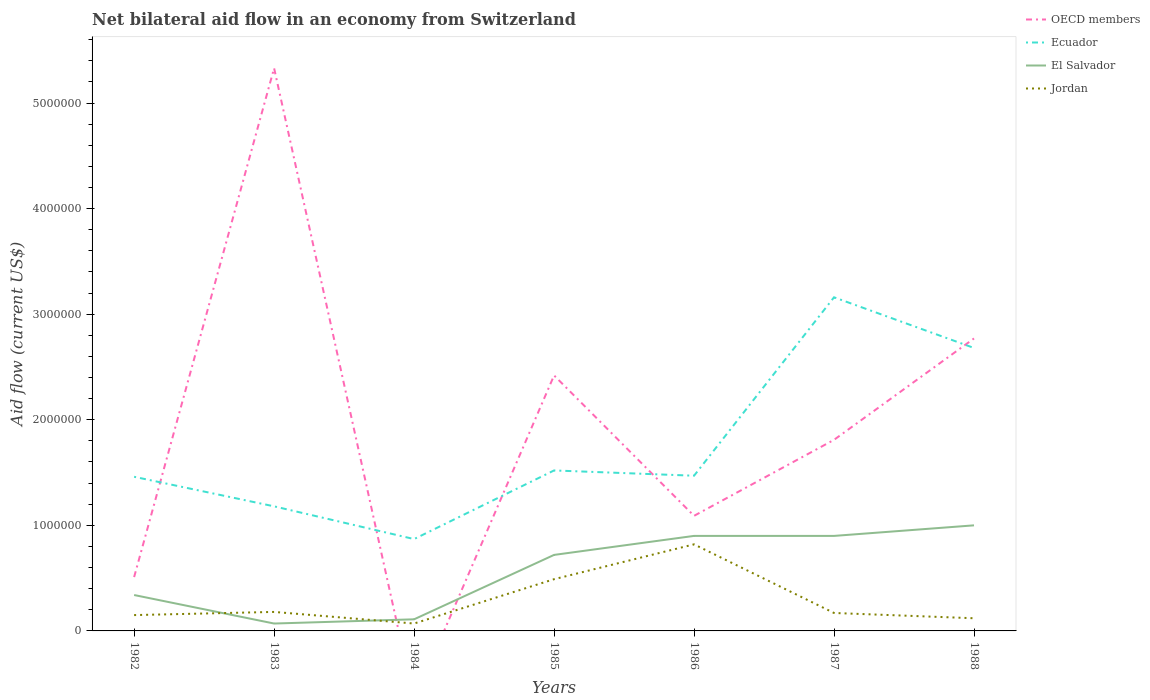How many different coloured lines are there?
Your answer should be very brief. 4. Is the number of lines equal to the number of legend labels?
Offer a very short reply. No. What is the difference between the highest and the second highest net bilateral aid flow in Ecuador?
Provide a short and direct response. 2.29e+06. What is the difference between the highest and the lowest net bilateral aid flow in Jordan?
Ensure brevity in your answer.  2. How many lines are there?
Keep it short and to the point. 4. How many years are there in the graph?
Make the answer very short. 7. Does the graph contain any zero values?
Offer a terse response. Yes. How many legend labels are there?
Your answer should be very brief. 4. What is the title of the graph?
Provide a succinct answer. Net bilateral aid flow in an economy from Switzerland. Does "United States" appear as one of the legend labels in the graph?
Your answer should be compact. No. What is the label or title of the X-axis?
Provide a short and direct response. Years. What is the label or title of the Y-axis?
Give a very brief answer. Aid flow (current US$). What is the Aid flow (current US$) of OECD members in 1982?
Your answer should be compact. 5.10e+05. What is the Aid flow (current US$) in Ecuador in 1982?
Provide a succinct answer. 1.46e+06. What is the Aid flow (current US$) of El Salvador in 1982?
Offer a very short reply. 3.40e+05. What is the Aid flow (current US$) of Jordan in 1982?
Make the answer very short. 1.50e+05. What is the Aid flow (current US$) of OECD members in 1983?
Give a very brief answer. 5.33e+06. What is the Aid flow (current US$) in Ecuador in 1983?
Make the answer very short. 1.18e+06. What is the Aid flow (current US$) in Jordan in 1983?
Offer a terse response. 1.80e+05. What is the Aid flow (current US$) in OECD members in 1984?
Provide a short and direct response. 0. What is the Aid flow (current US$) of Ecuador in 1984?
Provide a short and direct response. 8.70e+05. What is the Aid flow (current US$) of El Salvador in 1984?
Give a very brief answer. 1.10e+05. What is the Aid flow (current US$) of OECD members in 1985?
Make the answer very short. 2.42e+06. What is the Aid flow (current US$) in Ecuador in 1985?
Offer a very short reply. 1.52e+06. What is the Aid flow (current US$) in El Salvador in 1985?
Provide a succinct answer. 7.20e+05. What is the Aid flow (current US$) of OECD members in 1986?
Make the answer very short. 1.09e+06. What is the Aid flow (current US$) in Ecuador in 1986?
Your response must be concise. 1.47e+06. What is the Aid flow (current US$) in El Salvador in 1986?
Ensure brevity in your answer.  9.00e+05. What is the Aid flow (current US$) of Jordan in 1986?
Offer a terse response. 8.20e+05. What is the Aid flow (current US$) of OECD members in 1987?
Offer a terse response. 1.81e+06. What is the Aid flow (current US$) of Ecuador in 1987?
Your answer should be compact. 3.16e+06. What is the Aid flow (current US$) of Jordan in 1987?
Your answer should be compact. 1.70e+05. What is the Aid flow (current US$) of OECD members in 1988?
Keep it short and to the point. 2.77e+06. What is the Aid flow (current US$) in Ecuador in 1988?
Your answer should be compact. 2.68e+06. Across all years, what is the maximum Aid flow (current US$) of OECD members?
Your response must be concise. 5.33e+06. Across all years, what is the maximum Aid flow (current US$) of Ecuador?
Offer a very short reply. 3.16e+06. Across all years, what is the maximum Aid flow (current US$) in Jordan?
Your response must be concise. 8.20e+05. Across all years, what is the minimum Aid flow (current US$) of Ecuador?
Provide a short and direct response. 8.70e+05. Across all years, what is the minimum Aid flow (current US$) in El Salvador?
Make the answer very short. 7.00e+04. What is the total Aid flow (current US$) of OECD members in the graph?
Provide a succinct answer. 1.39e+07. What is the total Aid flow (current US$) of Ecuador in the graph?
Offer a very short reply. 1.23e+07. What is the total Aid flow (current US$) in El Salvador in the graph?
Offer a very short reply. 4.04e+06. What is the difference between the Aid flow (current US$) of OECD members in 1982 and that in 1983?
Your answer should be very brief. -4.82e+06. What is the difference between the Aid flow (current US$) in El Salvador in 1982 and that in 1983?
Ensure brevity in your answer.  2.70e+05. What is the difference between the Aid flow (current US$) in Ecuador in 1982 and that in 1984?
Provide a succinct answer. 5.90e+05. What is the difference between the Aid flow (current US$) of El Salvador in 1982 and that in 1984?
Offer a very short reply. 2.30e+05. What is the difference between the Aid flow (current US$) of Jordan in 1982 and that in 1984?
Provide a short and direct response. 8.00e+04. What is the difference between the Aid flow (current US$) of OECD members in 1982 and that in 1985?
Ensure brevity in your answer.  -1.91e+06. What is the difference between the Aid flow (current US$) in Ecuador in 1982 and that in 1985?
Offer a very short reply. -6.00e+04. What is the difference between the Aid flow (current US$) in El Salvador in 1982 and that in 1985?
Ensure brevity in your answer.  -3.80e+05. What is the difference between the Aid flow (current US$) in OECD members in 1982 and that in 1986?
Your response must be concise. -5.80e+05. What is the difference between the Aid flow (current US$) of El Salvador in 1982 and that in 1986?
Make the answer very short. -5.60e+05. What is the difference between the Aid flow (current US$) in Jordan in 1982 and that in 1986?
Offer a very short reply. -6.70e+05. What is the difference between the Aid flow (current US$) in OECD members in 1982 and that in 1987?
Your response must be concise. -1.30e+06. What is the difference between the Aid flow (current US$) of Ecuador in 1982 and that in 1987?
Your answer should be very brief. -1.70e+06. What is the difference between the Aid flow (current US$) in El Salvador in 1982 and that in 1987?
Your response must be concise. -5.60e+05. What is the difference between the Aid flow (current US$) of OECD members in 1982 and that in 1988?
Your answer should be very brief. -2.26e+06. What is the difference between the Aid flow (current US$) in Ecuador in 1982 and that in 1988?
Keep it short and to the point. -1.22e+06. What is the difference between the Aid flow (current US$) in El Salvador in 1982 and that in 1988?
Give a very brief answer. -6.60e+05. What is the difference between the Aid flow (current US$) in Ecuador in 1983 and that in 1984?
Your answer should be very brief. 3.10e+05. What is the difference between the Aid flow (current US$) in El Salvador in 1983 and that in 1984?
Your answer should be very brief. -4.00e+04. What is the difference between the Aid flow (current US$) of Jordan in 1983 and that in 1984?
Your response must be concise. 1.10e+05. What is the difference between the Aid flow (current US$) of OECD members in 1983 and that in 1985?
Your answer should be compact. 2.91e+06. What is the difference between the Aid flow (current US$) in El Salvador in 1983 and that in 1985?
Make the answer very short. -6.50e+05. What is the difference between the Aid flow (current US$) in Jordan in 1983 and that in 1985?
Offer a very short reply. -3.10e+05. What is the difference between the Aid flow (current US$) in OECD members in 1983 and that in 1986?
Make the answer very short. 4.24e+06. What is the difference between the Aid flow (current US$) in El Salvador in 1983 and that in 1986?
Your response must be concise. -8.30e+05. What is the difference between the Aid flow (current US$) of Jordan in 1983 and that in 1986?
Your response must be concise. -6.40e+05. What is the difference between the Aid flow (current US$) of OECD members in 1983 and that in 1987?
Your answer should be compact. 3.52e+06. What is the difference between the Aid flow (current US$) in Ecuador in 1983 and that in 1987?
Provide a succinct answer. -1.98e+06. What is the difference between the Aid flow (current US$) of El Salvador in 1983 and that in 1987?
Your answer should be very brief. -8.30e+05. What is the difference between the Aid flow (current US$) of OECD members in 1983 and that in 1988?
Keep it short and to the point. 2.56e+06. What is the difference between the Aid flow (current US$) of Ecuador in 1983 and that in 1988?
Keep it short and to the point. -1.50e+06. What is the difference between the Aid flow (current US$) of El Salvador in 1983 and that in 1988?
Your answer should be very brief. -9.30e+05. What is the difference between the Aid flow (current US$) of Jordan in 1983 and that in 1988?
Give a very brief answer. 6.00e+04. What is the difference between the Aid flow (current US$) in Ecuador in 1984 and that in 1985?
Ensure brevity in your answer.  -6.50e+05. What is the difference between the Aid flow (current US$) in El Salvador in 1984 and that in 1985?
Provide a succinct answer. -6.10e+05. What is the difference between the Aid flow (current US$) of Jordan in 1984 and that in 1985?
Offer a terse response. -4.20e+05. What is the difference between the Aid flow (current US$) in Ecuador in 1984 and that in 1986?
Give a very brief answer. -6.00e+05. What is the difference between the Aid flow (current US$) of El Salvador in 1984 and that in 1986?
Your answer should be compact. -7.90e+05. What is the difference between the Aid flow (current US$) of Jordan in 1984 and that in 1986?
Ensure brevity in your answer.  -7.50e+05. What is the difference between the Aid flow (current US$) of Ecuador in 1984 and that in 1987?
Your answer should be very brief. -2.29e+06. What is the difference between the Aid flow (current US$) of El Salvador in 1984 and that in 1987?
Keep it short and to the point. -7.90e+05. What is the difference between the Aid flow (current US$) of Ecuador in 1984 and that in 1988?
Give a very brief answer. -1.81e+06. What is the difference between the Aid flow (current US$) of El Salvador in 1984 and that in 1988?
Your answer should be very brief. -8.90e+05. What is the difference between the Aid flow (current US$) of Jordan in 1984 and that in 1988?
Give a very brief answer. -5.00e+04. What is the difference between the Aid flow (current US$) in OECD members in 1985 and that in 1986?
Ensure brevity in your answer.  1.33e+06. What is the difference between the Aid flow (current US$) in Ecuador in 1985 and that in 1986?
Offer a very short reply. 5.00e+04. What is the difference between the Aid flow (current US$) of Jordan in 1985 and that in 1986?
Offer a very short reply. -3.30e+05. What is the difference between the Aid flow (current US$) in OECD members in 1985 and that in 1987?
Your answer should be compact. 6.10e+05. What is the difference between the Aid flow (current US$) in Ecuador in 1985 and that in 1987?
Offer a terse response. -1.64e+06. What is the difference between the Aid flow (current US$) of El Salvador in 1985 and that in 1987?
Offer a very short reply. -1.80e+05. What is the difference between the Aid flow (current US$) of Jordan in 1985 and that in 1987?
Make the answer very short. 3.20e+05. What is the difference between the Aid flow (current US$) of OECD members in 1985 and that in 1988?
Provide a succinct answer. -3.50e+05. What is the difference between the Aid flow (current US$) of Ecuador in 1985 and that in 1988?
Ensure brevity in your answer.  -1.16e+06. What is the difference between the Aid flow (current US$) in El Salvador in 1985 and that in 1988?
Your answer should be very brief. -2.80e+05. What is the difference between the Aid flow (current US$) of Jordan in 1985 and that in 1988?
Ensure brevity in your answer.  3.70e+05. What is the difference between the Aid flow (current US$) in OECD members in 1986 and that in 1987?
Ensure brevity in your answer.  -7.20e+05. What is the difference between the Aid flow (current US$) in Ecuador in 1986 and that in 1987?
Your answer should be compact. -1.69e+06. What is the difference between the Aid flow (current US$) of El Salvador in 1986 and that in 1987?
Offer a very short reply. 0. What is the difference between the Aid flow (current US$) of Jordan in 1986 and that in 1987?
Ensure brevity in your answer.  6.50e+05. What is the difference between the Aid flow (current US$) in OECD members in 1986 and that in 1988?
Ensure brevity in your answer.  -1.68e+06. What is the difference between the Aid flow (current US$) of Ecuador in 1986 and that in 1988?
Offer a terse response. -1.21e+06. What is the difference between the Aid flow (current US$) in OECD members in 1987 and that in 1988?
Offer a terse response. -9.60e+05. What is the difference between the Aid flow (current US$) in Ecuador in 1987 and that in 1988?
Offer a very short reply. 4.80e+05. What is the difference between the Aid flow (current US$) of Jordan in 1987 and that in 1988?
Offer a terse response. 5.00e+04. What is the difference between the Aid flow (current US$) of OECD members in 1982 and the Aid flow (current US$) of Ecuador in 1983?
Provide a short and direct response. -6.70e+05. What is the difference between the Aid flow (current US$) in OECD members in 1982 and the Aid flow (current US$) in Jordan in 1983?
Your answer should be compact. 3.30e+05. What is the difference between the Aid flow (current US$) in Ecuador in 1982 and the Aid flow (current US$) in El Salvador in 1983?
Your response must be concise. 1.39e+06. What is the difference between the Aid flow (current US$) in Ecuador in 1982 and the Aid flow (current US$) in Jordan in 1983?
Offer a very short reply. 1.28e+06. What is the difference between the Aid flow (current US$) in El Salvador in 1982 and the Aid flow (current US$) in Jordan in 1983?
Your response must be concise. 1.60e+05. What is the difference between the Aid flow (current US$) of OECD members in 1982 and the Aid flow (current US$) of Ecuador in 1984?
Your response must be concise. -3.60e+05. What is the difference between the Aid flow (current US$) in OECD members in 1982 and the Aid flow (current US$) in Jordan in 1984?
Give a very brief answer. 4.40e+05. What is the difference between the Aid flow (current US$) of Ecuador in 1982 and the Aid flow (current US$) of El Salvador in 1984?
Keep it short and to the point. 1.35e+06. What is the difference between the Aid flow (current US$) in Ecuador in 1982 and the Aid flow (current US$) in Jordan in 1984?
Keep it short and to the point. 1.39e+06. What is the difference between the Aid flow (current US$) of OECD members in 1982 and the Aid flow (current US$) of Ecuador in 1985?
Your response must be concise. -1.01e+06. What is the difference between the Aid flow (current US$) in Ecuador in 1982 and the Aid flow (current US$) in El Salvador in 1985?
Provide a short and direct response. 7.40e+05. What is the difference between the Aid flow (current US$) of Ecuador in 1982 and the Aid flow (current US$) of Jordan in 1985?
Keep it short and to the point. 9.70e+05. What is the difference between the Aid flow (current US$) in OECD members in 1982 and the Aid flow (current US$) in Ecuador in 1986?
Ensure brevity in your answer.  -9.60e+05. What is the difference between the Aid flow (current US$) in OECD members in 1982 and the Aid flow (current US$) in El Salvador in 1986?
Offer a terse response. -3.90e+05. What is the difference between the Aid flow (current US$) in OECD members in 1982 and the Aid flow (current US$) in Jordan in 1986?
Your response must be concise. -3.10e+05. What is the difference between the Aid flow (current US$) of Ecuador in 1982 and the Aid flow (current US$) of El Salvador in 1986?
Provide a short and direct response. 5.60e+05. What is the difference between the Aid flow (current US$) in Ecuador in 1982 and the Aid flow (current US$) in Jordan in 1986?
Provide a succinct answer. 6.40e+05. What is the difference between the Aid flow (current US$) of El Salvador in 1982 and the Aid flow (current US$) of Jordan in 1986?
Provide a short and direct response. -4.80e+05. What is the difference between the Aid flow (current US$) of OECD members in 1982 and the Aid flow (current US$) of Ecuador in 1987?
Keep it short and to the point. -2.65e+06. What is the difference between the Aid flow (current US$) in OECD members in 1982 and the Aid flow (current US$) in El Salvador in 1987?
Provide a succinct answer. -3.90e+05. What is the difference between the Aid flow (current US$) of OECD members in 1982 and the Aid flow (current US$) of Jordan in 1987?
Offer a very short reply. 3.40e+05. What is the difference between the Aid flow (current US$) in Ecuador in 1982 and the Aid flow (current US$) in El Salvador in 1987?
Your answer should be compact. 5.60e+05. What is the difference between the Aid flow (current US$) in Ecuador in 1982 and the Aid flow (current US$) in Jordan in 1987?
Ensure brevity in your answer.  1.29e+06. What is the difference between the Aid flow (current US$) of OECD members in 1982 and the Aid flow (current US$) of Ecuador in 1988?
Your response must be concise. -2.17e+06. What is the difference between the Aid flow (current US$) in OECD members in 1982 and the Aid flow (current US$) in El Salvador in 1988?
Ensure brevity in your answer.  -4.90e+05. What is the difference between the Aid flow (current US$) in OECD members in 1982 and the Aid flow (current US$) in Jordan in 1988?
Your answer should be very brief. 3.90e+05. What is the difference between the Aid flow (current US$) of Ecuador in 1982 and the Aid flow (current US$) of El Salvador in 1988?
Offer a terse response. 4.60e+05. What is the difference between the Aid flow (current US$) in Ecuador in 1982 and the Aid flow (current US$) in Jordan in 1988?
Ensure brevity in your answer.  1.34e+06. What is the difference between the Aid flow (current US$) in El Salvador in 1982 and the Aid flow (current US$) in Jordan in 1988?
Give a very brief answer. 2.20e+05. What is the difference between the Aid flow (current US$) of OECD members in 1983 and the Aid flow (current US$) of Ecuador in 1984?
Your answer should be very brief. 4.46e+06. What is the difference between the Aid flow (current US$) of OECD members in 1983 and the Aid flow (current US$) of El Salvador in 1984?
Keep it short and to the point. 5.22e+06. What is the difference between the Aid flow (current US$) in OECD members in 1983 and the Aid flow (current US$) in Jordan in 1984?
Provide a short and direct response. 5.26e+06. What is the difference between the Aid flow (current US$) of Ecuador in 1983 and the Aid flow (current US$) of El Salvador in 1984?
Give a very brief answer. 1.07e+06. What is the difference between the Aid flow (current US$) of Ecuador in 1983 and the Aid flow (current US$) of Jordan in 1984?
Ensure brevity in your answer.  1.11e+06. What is the difference between the Aid flow (current US$) of El Salvador in 1983 and the Aid flow (current US$) of Jordan in 1984?
Provide a succinct answer. 0. What is the difference between the Aid flow (current US$) in OECD members in 1983 and the Aid flow (current US$) in Ecuador in 1985?
Your answer should be compact. 3.81e+06. What is the difference between the Aid flow (current US$) of OECD members in 1983 and the Aid flow (current US$) of El Salvador in 1985?
Offer a very short reply. 4.61e+06. What is the difference between the Aid flow (current US$) of OECD members in 1983 and the Aid flow (current US$) of Jordan in 1985?
Provide a succinct answer. 4.84e+06. What is the difference between the Aid flow (current US$) in Ecuador in 1983 and the Aid flow (current US$) in El Salvador in 1985?
Offer a very short reply. 4.60e+05. What is the difference between the Aid flow (current US$) of Ecuador in 1983 and the Aid flow (current US$) of Jordan in 1985?
Provide a succinct answer. 6.90e+05. What is the difference between the Aid flow (current US$) in El Salvador in 1983 and the Aid flow (current US$) in Jordan in 1985?
Give a very brief answer. -4.20e+05. What is the difference between the Aid flow (current US$) in OECD members in 1983 and the Aid flow (current US$) in Ecuador in 1986?
Make the answer very short. 3.86e+06. What is the difference between the Aid flow (current US$) of OECD members in 1983 and the Aid flow (current US$) of El Salvador in 1986?
Ensure brevity in your answer.  4.43e+06. What is the difference between the Aid flow (current US$) in OECD members in 1983 and the Aid flow (current US$) in Jordan in 1986?
Your answer should be compact. 4.51e+06. What is the difference between the Aid flow (current US$) of Ecuador in 1983 and the Aid flow (current US$) of El Salvador in 1986?
Provide a short and direct response. 2.80e+05. What is the difference between the Aid flow (current US$) of Ecuador in 1983 and the Aid flow (current US$) of Jordan in 1986?
Keep it short and to the point. 3.60e+05. What is the difference between the Aid flow (current US$) in El Salvador in 1983 and the Aid flow (current US$) in Jordan in 1986?
Make the answer very short. -7.50e+05. What is the difference between the Aid flow (current US$) of OECD members in 1983 and the Aid flow (current US$) of Ecuador in 1987?
Ensure brevity in your answer.  2.17e+06. What is the difference between the Aid flow (current US$) in OECD members in 1983 and the Aid flow (current US$) in El Salvador in 1987?
Give a very brief answer. 4.43e+06. What is the difference between the Aid flow (current US$) in OECD members in 1983 and the Aid flow (current US$) in Jordan in 1987?
Offer a terse response. 5.16e+06. What is the difference between the Aid flow (current US$) of Ecuador in 1983 and the Aid flow (current US$) of Jordan in 1987?
Give a very brief answer. 1.01e+06. What is the difference between the Aid flow (current US$) in El Salvador in 1983 and the Aid flow (current US$) in Jordan in 1987?
Offer a terse response. -1.00e+05. What is the difference between the Aid flow (current US$) in OECD members in 1983 and the Aid flow (current US$) in Ecuador in 1988?
Make the answer very short. 2.65e+06. What is the difference between the Aid flow (current US$) of OECD members in 1983 and the Aid flow (current US$) of El Salvador in 1988?
Offer a terse response. 4.33e+06. What is the difference between the Aid flow (current US$) of OECD members in 1983 and the Aid flow (current US$) of Jordan in 1988?
Give a very brief answer. 5.21e+06. What is the difference between the Aid flow (current US$) of Ecuador in 1983 and the Aid flow (current US$) of El Salvador in 1988?
Make the answer very short. 1.80e+05. What is the difference between the Aid flow (current US$) in Ecuador in 1983 and the Aid flow (current US$) in Jordan in 1988?
Your answer should be very brief. 1.06e+06. What is the difference between the Aid flow (current US$) of El Salvador in 1983 and the Aid flow (current US$) of Jordan in 1988?
Keep it short and to the point. -5.00e+04. What is the difference between the Aid flow (current US$) of El Salvador in 1984 and the Aid flow (current US$) of Jordan in 1985?
Offer a very short reply. -3.80e+05. What is the difference between the Aid flow (current US$) in Ecuador in 1984 and the Aid flow (current US$) in Jordan in 1986?
Ensure brevity in your answer.  5.00e+04. What is the difference between the Aid flow (current US$) of El Salvador in 1984 and the Aid flow (current US$) of Jordan in 1986?
Offer a terse response. -7.10e+05. What is the difference between the Aid flow (current US$) of Ecuador in 1984 and the Aid flow (current US$) of Jordan in 1987?
Provide a short and direct response. 7.00e+05. What is the difference between the Aid flow (current US$) in El Salvador in 1984 and the Aid flow (current US$) in Jordan in 1987?
Ensure brevity in your answer.  -6.00e+04. What is the difference between the Aid flow (current US$) of Ecuador in 1984 and the Aid flow (current US$) of Jordan in 1988?
Offer a very short reply. 7.50e+05. What is the difference between the Aid flow (current US$) of El Salvador in 1984 and the Aid flow (current US$) of Jordan in 1988?
Provide a succinct answer. -10000. What is the difference between the Aid flow (current US$) of OECD members in 1985 and the Aid flow (current US$) of Ecuador in 1986?
Ensure brevity in your answer.  9.50e+05. What is the difference between the Aid flow (current US$) of OECD members in 1985 and the Aid flow (current US$) of El Salvador in 1986?
Your answer should be very brief. 1.52e+06. What is the difference between the Aid flow (current US$) of OECD members in 1985 and the Aid flow (current US$) of Jordan in 1986?
Keep it short and to the point. 1.60e+06. What is the difference between the Aid flow (current US$) of Ecuador in 1985 and the Aid flow (current US$) of El Salvador in 1986?
Offer a very short reply. 6.20e+05. What is the difference between the Aid flow (current US$) in El Salvador in 1985 and the Aid flow (current US$) in Jordan in 1986?
Your answer should be very brief. -1.00e+05. What is the difference between the Aid flow (current US$) of OECD members in 1985 and the Aid flow (current US$) of Ecuador in 1987?
Offer a very short reply. -7.40e+05. What is the difference between the Aid flow (current US$) in OECD members in 1985 and the Aid flow (current US$) in El Salvador in 1987?
Your answer should be very brief. 1.52e+06. What is the difference between the Aid flow (current US$) in OECD members in 1985 and the Aid flow (current US$) in Jordan in 1987?
Keep it short and to the point. 2.25e+06. What is the difference between the Aid flow (current US$) of Ecuador in 1985 and the Aid flow (current US$) of El Salvador in 1987?
Your response must be concise. 6.20e+05. What is the difference between the Aid flow (current US$) of Ecuador in 1985 and the Aid flow (current US$) of Jordan in 1987?
Your answer should be very brief. 1.35e+06. What is the difference between the Aid flow (current US$) of OECD members in 1985 and the Aid flow (current US$) of Ecuador in 1988?
Give a very brief answer. -2.60e+05. What is the difference between the Aid flow (current US$) in OECD members in 1985 and the Aid flow (current US$) in El Salvador in 1988?
Ensure brevity in your answer.  1.42e+06. What is the difference between the Aid flow (current US$) of OECD members in 1985 and the Aid flow (current US$) of Jordan in 1988?
Offer a terse response. 2.30e+06. What is the difference between the Aid flow (current US$) of Ecuador in 1985 and the Aid flow (current US$) of El Salvador in 1988?
Your response must be concise. 5.20e+05. What is the difference between the Aid flow (current US$) in Ecuador in 1985 and the Aid flow (current US$) in Jordan in 1988?
Your answer should be compact. 1.40e+06. What is the difference between the Aid flow (current US$) in OECD members in 1986 and the Aid flow (current US$) in Ecuador in 1987?
Provide a short and direct response. -2.07e+06. What is the difference between the Aid flow (current US$) in OECD members in 1986 and the Aid flow (current US$) in Jordan in 1987?
Offer a very short reply. 9.20e+05. What is the difference between the Aid flow (current US$) in Ecuador in 1986 and the Aid flow (current US$) in El Salvador in 1987?
Provide a short and direct response. 5.70e+05. What is the difference between the Aid flow (current US$) in Ecuador in 1986 and the Aid flow (current US$) in Jordan in 1987?
Ensure brevity in your answer.  1.30e+06. What is the difference between the Aid flow (current US$) of El Salvador in 1986 and the Aid flow (current US$) of Jordan in 1987?
Your answer should be very brief. 7.30e+05. What is the difference between the Aid flow (current US$) in OECD members in 1986 and the Aid flow (current US$) in Ecuador in 1988?
Keep it short and to the point. -1.59e+06. What is the difference between the Aid flow (current US$) in OECD members in 1986 and the Aid flow (current US$) in Jordan in 1988?
Your answer should be compact. 9.70e+05. What is the difference between the Aid flow (current US$) of Ecuador in 1986 and the Aid flow (current US$) of El Salvador in 1988?
Your response must be concise. 4.70e+05. What is the difference between the Aid flow (current US$) of Ecuador in 1986 and the Aid flow (current US$) of Jordan in 1988?
Your response must be concise. 1.35e+06. What is the difference between the Aid flow (current US$) of El Salvador in 1986 and the Aid flow (current US$) of Jordan in 1988?
Keep it short and to the point. 7.80e+05. What is the difference between the Aid flow (current US$) of OECD members in 1987 and the Aid flow (current US$) of Ecuador in 1988?
Provide a short and direct response. -8.70e+05. What is the difference between the Aid flow (current US$) of OECD members in 1987 and the Aid flow (current US$) of El Salvador in 1988?
Ensure brevity in your answer.  8.10e+05. What is the difference between the Aid flow (current US$) in OECD members in 1987 and the Aid flow (current US$) in Jordan in 1988?
Offer a terse response. 1.69e+06. What is the difference between the Aid flow (current US$) in Ecuador in 1987 and the Aid flow (current US$) in El Salvador in 1988?
Provide a succinct answer. 2.16e+06. What is the difference between the Aid flow (current US$) in Ecuador in 1987 and the Aid flow (current US$) in Jordan in 1988?
Ensure brevity in your answer.  3.04e+06. What is the difference between the Aid flow (current US$) of El Salvador in 1987 and the Aid flow (current US$) of Jordan in 1988?
Give a very brief answer. 7.80e+05. What is the average Aid flow (current US$) in OECD members per year?
Your answer should be very brief. 1.99e+06. What is the average Aid flow (current US$) of Ecuador per year?
Keep it short and to the point. 1.76e+06. What is the average Aid flow (current US$) of El Salvador per year?
Make the answer very short. 5.77e+05. What is the average Aid flow (current US$) in Jordan per year?
Give a very brief answer. 2.86e+05. In the year 1982, what is the difference between the Aid flow (current US$) in OECD members and Aid flow (current US$) in Ecuador?
Offer a terse response. -9.50e+05. In the year 1982, what is the difference between the Aid flow (current US$) in OECD members and Aid flow (current US$) in El Salvador?
Your answer should be very brief. 1.70e+05. In the year 1982, what is the difference between the Aid flow (current US$) in OECD members and Aid flow (current US$) in Jordan?
Provide a short and direct response. 3.60e+05. In the year 1982, what is the difference between the Aid flow (current US$) of Ecuador and Aid flow (current US$) of El Salvador?
Make the answer very short. 1.12e+06. In the year 1982, what is the difference between the Aid flow (current US$) in Ecuador and Aid flow (current US$) in Jordan?
Give a very brief answer. 1.31e+06. In the year 1982, what is the difference between the Aid flow (current US$) of El Salvador and Aid flow (current US$) of Jordan?
Offer a very short reply. 1.90e+05. In the year 1983, what is the difference between the Aid flow (current US$) in OECD members and Aid flow (current US$) in Ecuador?
Your answer should be very brief. 4.15e+06. In the year 1983, what is the difference between the Aid flow (current US$) in OECD members and Aid flow (current US$) in El Salvador?
Ensure brevity in your answer.  5.26e+06. In the year 1983, what is the difference between the Aid flow (current US$) in OECD members and Aid flow (current US$) in Jordan?
Offer a terse response. 5.15e+06. In the year 1983, what is the difference between the Aid flow (current US$) of Ecuador and Aid flow (current US$) of El Salvador?
Keep it short and to the point. 1.11e+06. In the year 1983, what is the difference between the Aid flow (current US$) in Ecuador and Aid flow (current US$) in Jordan?
Give a very brief answer. 1.00e+06. In the year 1984, what is the difference between the Aid flow (current US$) in Ecuador and Aid flow (current US$) in El Salvador?
Offer a terse response. 7.60e+05. In the year 1984, what is the difference between the Aid flow (current US$) of El Salvador and Aid flow (current US$) of Jordan?
Make the answer very short. 4.00e+04. In the year 1985, what is the difference between the Aid flow (current US$) of OECD members and Aid flow (current US$) of Ecuador?
Offer a terse response. 9.00e+05. In the year 1985, what is the difference between the Aid flow (current US$) of OECD members and Aid flow (current US$) of El Salvador?
Your answer should be very brief. 1.70e+06. In the year 1985, what is the difference between the Aid flow (current US$) in OECD members and Aid flow (current US$) in Jordan?
Provide a short and direct response. 1.93e+06. In the year 1985, what is the difference between the Aid flow (current US$) of Ecuador and Aid flow (current US$) of Jordan?
Your answer should be very brief. 1.03e+06. In the year 1986, what is the difference between the Aid flow (current US$) of OECD members and Aid flow (current US$) of Ecuador?
Provide a succinct answer. -3.80e+05. In the year 1986, what is the difference between the Aid flow (current US$) of OECD members and Aid flow (current US$) of El Salvador?
Make the answer very short. 1.90e+05. In the year 1986, what is the difference between the Aid flow (current US$) of Ecuador and Aid flow (current US$) of El Salvador?
Your response must be concise. 5.70e+05. In the year 1986, what is the difference between the Aid flow (current US$) in Ecuador and Aid flow (current US$) in Jordan?
Provide a short and direct response. 6.50e+05. In the year 1987, what is the difference between the Aid flow (current US$) of OECD members and Aid flow (current US$) of Ecuador?
Provide a succinct answer. -1.35e+06. In the year 1987, what is the difference between the Aid flow (current US$) in OECD members and Aid flow (current US$) in El Salvador?
Your answer should be compact. 9.10e+05. In the year 1987, what is the difference between the Aid flow (current US$) in OECD members and Aid flow (current US$) in Jordan?
Give a very brief answer. 1.64e+06. In the year 1987, what is the difference between the Aid flow (current US$) of Ecuador and Aid flow (current US$) of El Salvador?
Your response must be concise. 2.26e+06. In the year 1987, what is the difference between the Aid flow (current US$) in Ecuador and Aid flow (current US$) in Jordan?
Ensure brevity in your answer.  2.99e+06. In the year 1987, what is the difference between the Aid flow (current US$) of El Salvador and Aid flow (current US$) of Jordan?
Provide a succinct answer. 7.30e+05. In the year 1988, what is the difference between the Aid flow (current US$) in OECD members and Aid flow (current US$) in Ecuador?
Your response must be concise. 9.00e+04. In the year 1988, what is the difference between the Aid flow (current US$) in OECD members and Aid flow (current US$) in El Salvador?
Ensure brevity in your answer.  1.77e+06. In the year 1988, what is the difference between the Aid flow (current US$) in OECD members and Aid flow (current US$) in Jordan?
Ensure brevity in your answer.  2.65e+06. In the year 1988, what is the difference between the Aid flow (current US$) of Ecuador and Aid flow (current US$) of El Salvador?
Give a very brief answer. 1.68e+06. In the year 1988, what is the difference between the Aid flow (current US$) in Ecuador and Aid flow (current US$) in Jordan?
Ensure brevity in your answer.  2.56e+06. In the year 1988, what is the difference between the Aid flow (current US$) of El Salvador and Aid flow (current US$) of Jordan?
Make the answer very short. 8.80e+05. What is the ratio of the Aid flow (current US$) in OECD members in 1982 to that in 1983?
Provide a succinct answer. 0.1. What is the ratio of the Aid flow (current US$) in Ecuador in 1982 to that in 1983?
Offer a terse response. 1.24. What is the ratio of the Aid flow (current US$) in El Salvador in 1982 to that in 1983?
Give a very brief answer. 4.86. What is the ratio of the Aid flow (current US$) in Jordan in 1982 to that in 1983?
Offer a terse response. 0.83. What is the ratio of the Aid flow (current US$) in Ecuador in 1982 to that in 1984?
Your answer should be compact. 1.68. What is the ratio of the Aid flow (current US$) in El Salvador in 1982 to that in 1984?
Provide a succinct answer. 3.09. What is the ratio of the Aid flow (current US$) of Jordan in 1982 to that in 1984?
Make the answer very short. 2.14. What is the ratio of the Aid flow (current US$) in OECD members in 1982 to that in 1985?
Your response must be concise. 0.21. What is the ratio of the Aid flow (current US$) in Ecuador in 1982 to that in 1985?
Offer a very short reply. 0.96. What is the ratio of the Aid flow (current US$) of El Salvador in 1982 to that in 1985?
Your response must be concise. 0.47. What is the ratio of the Aid flow (current US$) in Jordan in 1982 to that in 1985?
Ensure brevity in your answer.  0.31. What is the ratio of the Aid flow (current US$) in OECD members in 1982 to that in 1986?
Make the answer very short. 0.47. What is the ratio of the Aid flow (current US$) in El Salvador in 1982 to that in 1986?
Give a very brief answer. 0.38. What is the ratio of the Aid flow (current US$) in Jordan in 1982 to that in 1986?
Your answer should be compact. 0.18. What is the ratio of the Aid flow (current US$) in OECD members in 1982 to that in 1987?
Offer a very short reply. 0.28. What is the ratio of the Aid flow (current US$) of Ecuador in 1982 to that in 1987?
Ensure brevity in your answer.  0.46. What is the ratio of the Aid flow (current US$) in El Salvador in 1982 to that in 1987?
Offer a very short reply. 0.38. What is the ratio of the Aid flow (current US$) of Jordan in 1982 to that in 1987?
Give a very brief answer. 0.88. What is the ratio of the Aid flow (current US$) in OECD members in 1982 to that in 1988?
Ensure brevity in your answer.  0.18. What is the ratio of the Aid flow (current US$) of Ecuador in 1982 to that in 1988?
Your answer should be compact. 0.54. What is the ratio of the Aid flow (current US$) of El Salvador in 1982 to that in 1988?
Your answer should be very brief. 0.34. What is the ratio of the Aid flow (current US$) in Jordan in 1982 to that in 1988?
Keep it short and to the point. 1.25. What is the ratio of the Aid flow (current US$) of Ecuador in 1983 to that in 1984?
Provide a succinct answer. 1.36. What is the ratio of the Aid flow (current US$) in El Salvador in 1983 to that in 1984?
Keep it short and to the point. 0.64. What is the ratio of the Aid flow (current US$) in Jordan in 1983 to that in 1984?
Keep it short and to the point. 2.57. What is the ratio of the Aid flow (current US$) of OECD members in 1983 to that in 1985?
Your answer should be very brief. 2.2. What is the ratio of the Aid flow (current US$) in Ecuador in 1983 to that in 1985?
Give a very brief answer. 0.78. What is the ratio of the Aid flow (current US$) in El Salvador in 1983 to that in 1985?
Ensure brevity in your answer.  0.1. What is the ratio of the Aid flow (current US$) in Jordan in 1983 to that in 1985?
Provide a short and direct response. 0.37. What is the ratio of the Aid flow (current US$) in OECD members in 1983 to that in 1986?
Offer a terse response. 4.89. What is the ratio of the Aid flow (current US$) in Ecuador in 1983 to that in 1986?
Your answer should be very brief. 0.8. What is the ratio of the Aid flow (current US$) in El Salvador in 1983 to that in 1986?
Your response must be concise. 0.08. What is the ratio of the Aid flow (current US$) of Jordan in 1983 to that in 1986?
Offer a terse response. 0.22. What is the ratio of the Aid flow (current US$) of OECD members in 1983 to that in 1987?
Offer a very short reply. 2.94. What is the ratio of the Aid flow (current US$) of Ecuador in 1983 to that in 1987?
Your answer should be very brief. 0.37. What is the ratio of the Aid flow (current US$) of El Salvador in 1983 to that in 1987?
Provide a short and direct response. 0.08. What is the ratio of the Aid flow (current US$) of Jordan in 1983 to that in 1987?
Provide a succinct answer. 1.06. What is the ratio of the Aid flow (current US$) of OECD members in 1983 to that in 1988?
Give a very brief answer. 1.92. What is the ratio of the Aid flow (current US$) of Ecuador in 1983 to that in 1988?
Your answer should be very brief. 0.44. What is the ratio of the Aid flow (current US$) of El Salvador in 1983 to that in 1988?
Keep it short and to the point. 0.07. What is the ratio of the Aid flow (current US$) in Jordan in 1983 to that in 1988?
Make the answer very short. 1.5. What is the ratio of the Aid flow (current US$) in Ecuador in 1984 to that in 1985?
Provide a succinct answer. 0.57. What is the ratio of the Aid flow (current US$) in El Salvador in 1984 to that in 1985?
Your answer should be very brief. 0.15. What is the ratio of the Aid flow (current US$) of Jordan in 1984 to that in 1985?
Your response must be concise. 0.14. What is the ratio of the Aid flow (current US$) of Ecuador in 1984 to that in 1986?
Your answer should be very brief. 0.59. What is the ratio of the Aid flow (current US$) in El Salvador in 1984 to that in 1986?
Your answer should be compact. 0.12. What is the ratio of the Aid flow (current US$) in Jordan in 1984 to that in 1986?
Ensure brevity in your answer.  0.09. What is the ratio of the Aid flow (current US$) in Ecuador in 1984 to that in 1987?
Provide a succinct answer. 0.28. What is the ratio of the Aid flow (current US$) of El Salvador in 1984 to that in 1987?
Ensure brevity in your answer.  0.12. What is the ratio of the Aid flow (current US$) of Jordan in 1984 to that in 1987?
Offer a terse response. 0.41. What is the ratio of the Aid flow (current US$) of Ecuador in 1984 to that in 1988?
Give a very brief answer. 0.32. What is the ratio of the Aid flow (current US$) of El Salvador in 1984 to that in 1988?
Keep it short and to the point. 0.11. What is the ratio of the Aid flow (current US$) of Jordan in 1984 to that in 1988?
Your answer should be very brief. 0.58. What is the ratio of the Aid flow (current US$) of OECD members in 1985 to that in 1986?
Keep it short and to the point. 2.22. What is the ratio of the Aid flow (current US$) of Ecuador in 1985 to that in 1986?
Give a very brief answer. 1.03. What is the ratio of the Aid flow (current US$) of Jordan in 1985 to that in 1986?
Offer a terse response. 0.6. What is the ratio of the Aid flow (current US$) of OECD members in 1985 to that in 1987?
Offer a very short reply. 1.34. What is the ratio of the Aid flow (current US$) of Ecuador in 1985 to that in 1987?
Ensure brevity in your answer.  0.48. What is the ratio of the Aid flow (current US$) of Jordan in 1985 to that in 1987?
Provide a succinct answer. 2.88. What is the ratio of the Aid flow (current US$) in OECD members in 1985 to that in 1988?
Offer a terse response. 0.87. What is the ratio of the Aid flow (current US$) in Ecuador in 1985 to that in 1988?
Your answer should be compact. 0.57. What is the ratio of the Aid flow (current US$) of El Salvador in 1985 to that in 1988?
Ensure brevity in your answer.  0.72. What is the ratio of the Aid flow (current US$) in Jordan in 1985 to that in 1988?
Provide a succinct answer. 4.08. What is the ratio of the Aid flow (current US$) in OECD members in 1986 to that in 1987?
Your answer should be compact. 0.6. What is the ratio of the Aid flow (current US$) of Ecuador in 1986 to that in 1987?
Give a very brief answer. 0.47. What is the ratio of the Aid flow (current US$) of El Salvador in 1986 to that in 1987?
Keep it short and to the point. 1. What is the ratio of the Aid flow (current US$) in Jordan in 1986 to that in 1987?
Ensure brevity in your answer.  4.82. What is the ratio of the Aid flow (current US$) in OECD members in 1986 to that in 1988?
Ensure brevity in your answer.  0.39. What is the ratio of the Aid flow (current US$) in Ecuador in 1986 to that in 1988?
Make the answer very short. 0.55. What is the ratio of the Aid flow (current US$) in Jordan in 1986 to that in 1988?
Your answer should be very brief. 6.83. What is the ratio of the Aid flow (current US$) in OECD members in 1987 to that in 1988?
Your answer should be very brief. 0.65. What is the ratio of the Aid flow (current US$) of Ecuador in 1987 to that in 1988?
Offer a very short reply. 1.18. What is the ratio of the Aid flow (current US$) of Jordan in 1987 to that in 1988?
Provide a succinct answer. 1.42. What is the difference between the highest and the second highest Aid flow (current US$) in OECD members?
Your answer should be very brief. 2.56e+06. What is the difference between the highest and the second highest Aid flow (current US$) of Ecuador?
Keep it short and to the point. 4.80e+05. What is the difference between the highest and the second highest Aid flow (current US$) of El Salvador?
Offer a very short reply. 1.00e+05. What is the difference between the highest and the lowest Aid flow (current US$) of OECD members?
Offer a terse response. 5.33e+06. What is the difference between the highest and the lowest Aid flow (current US$) in Ecuador?
Your answer should be very brief. 2.29e+06. What is the difference between the highest and the lowest Aid flow (current US$) in El Salvador?
Keep it short and to the point. 9.30e+05. What is the difference between the highest and the lowest Aid flow (current US$) in Jordan?
Provide a succinct answer. 7.50e+05. 